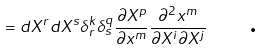<formula> <loc_0><loc_0><loc_500><loc_500>= d X ^ { r } d X ^ { s } \delta _ { r } ^ { k } \delta _ { s } ^ { q } \frac { \partial X ^ { p } } { \partial x ^ { m } } \frac { \partial ^ { 2 } x ^ { m } } { \partial X ^ { i } \partial X ^ { j } } \text { \quad .}</formula> 